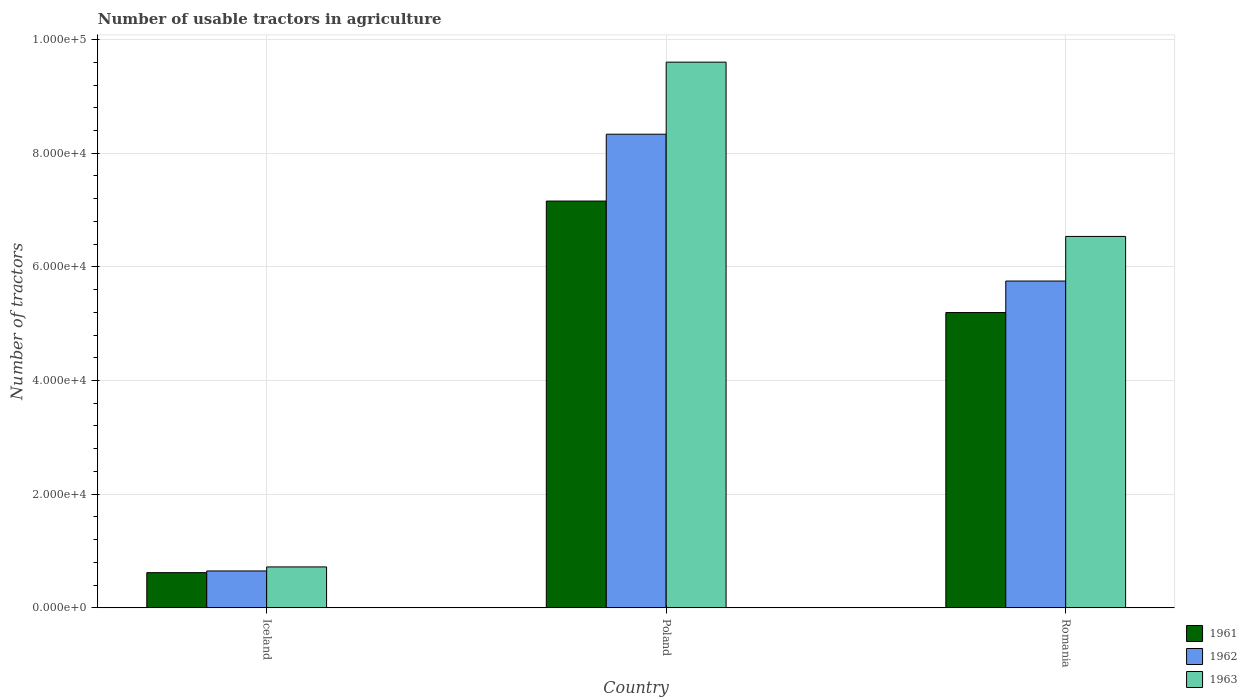How many bars are there on the 2nd tick from the left?
Your answer should be compact. 3. What is the label of the 3rd group of bars from the left?
Ensure brevity in your answer.  Romania. What is the number of usable tractors in agriculture in 1963 in Romania?
Offer a terse response. 6.54e+04. Across all countries, what is the maximum number of usable tractors in agriculture in 1961?
Make the answer very short. 7.16e+04. Across all countries, what is the minimum number of usable tractors in agriculture in 1963?
Keep it short and to the point. 7187. In which country was the number of usable tractors in agriculture in 1961 maximum?
Offer a terse response. Poland. What is the total number of usable tractors in agriculture in 1961 in the graph?
Your response must be concise. 1.30e+05. What is the difference between the number of usable tractors in agriculture in 1963 in Iceland and that in Romania?
Keep it short and to the point. -5.82e+04. What is the difference between the number of usable tractors in agriculture in 1962 in Iceland and the number of usable tractors in agriculture in 1961 in Poland?
Offer a terse response. -6.51e+04. What is the average number of usable tractors in agriculture in 1963 per country?
Your answer should be very brief. 5.62e+04. What is the difference between the number of usable tractors in agriculture of/in 1963 and number of usable tractors in agriculture of/in 1962 in Poland?
Give a very brief answer. 1.27e+04. In how many countries, is the number of usable tractors in agriculture in 1963 greater than 24000?
Your response must be concise. 2. What is the ratio of the number of usable tractors in agriculture in 1961 in Iceland to that in Romania?
Give a very brief answer. 0.12. Is the difference between the number of usable tractors in agriculture in 1963 in Iceland and Poland greater than the difference between the number of usable tractors in agriculture in 1962 in Iceland and Poland?
Your answer should be compact. No. What is the difference between the highest and the second highest number of usable tractors in agriculture in 1963?
Offer a very short reply. -8.88e+04. What is the difference between the highest and the lowest number of usable tractors in agriculture in 1961?
Offer a terse response. 6.54e+04. Is it the case that in every country, the sum of the number of usable tractors in agriculture in 1963 and number of usable tractors in agriculture in 1962 is greater than the number of usable tractors in agriculture in 1961?
Give a very brief answer. Yes. Are the values on the major ticks of Y-axis written in scientific E-notation?
Provide a succinct answer. Yes. Does the graph contain any zero values?
Your answer should be very brief. No. Where does the legend appear in the graph?
Your response must be concise. Bottom right. How many legend labels are there?
Your response must be concise. 3. How are the legend labels stacked?
Offer a very short reply. Vertical. What is the title of the graph?
Provide a short and direct response. Number of usable tractors in agriculture. Does "1993" appear as one of the legend labels in the graph?
Provide a short and direct response. No. What is the label or title of the X-axis?
Keep it short and to the point. Country. What is the label or title of the Y-axis?
Provide a short and direct response. Number of tractors. What is the Number of tractors in 1961 in Iceland?
Your answer should be very brief. 6177. What is the Number of tractors of 1962 in Iceland?
Give a very brief answer. 6479. What is the Number of tractors in 1963 in Iceland?
Make the answer very short. 7187. What is the Number of tractors in 1961 in Poland?
Your answer should be compact. 7.16e+04. What is the Number of tractors of 1962 in Poland?
Your answer should be very brief. 8.33e+04. What is the Number of tractors in 1963 in Poland?
Keep it short and to the point. 9.60e+04. What is the Number of tractors in 1961 in Romania?
Provide a short and direct response. 5.20e+04. What is the Number of tractors in 1962 in Romania?
Keep it short and to the point. 5.75e+04. What is the Number of tractors in 1963 in Romania?
Offer a terse response. 6.54e+04. Across all countries, what is the maximum Number of tractors in 1961?
Provide a succinct answer. 7.16e+04. Across all countries, what is the maximum Number of tractors of 1962?
Keep it short and to the point. 8.33e+04. Across all countries, what is the maximum Number of tractors in 1963?
Keep it short and to the point. 9.60e+04. Across all countries, what is the minimum Number of tractors in 1961?
Your answer should be compact. 6177. Across all countries, what is the minimum Number of tractors of 1962?
Offer a very short reply. 6479. Across all countries, what is the minimum Number of tractors in 1963?
Your response must be concise. 7187. What is the total Number of tractors of 1961 in the graph?
Provide a succinct answer. 1.30e+05. What is the total Number of tractors of 1962 in the graph?
Give a very brief answer. 1.47e+05. What is the total Number of tractors of 1963 in the graph?
Provide a short and direct response. 1.69e+05. What is the difference between the Number of tractors of 1961 in Iceland and that in Poland?
Provide a succinct answer. -6.54e+04. What is the difference between the Number of tractors of 1962 in Iceland and that in Poland?
Offer a very short reply. -7.69e+04. What is the difference between the Number of tractors in 1963 in Iceland and that in Poland?
Provide a succinct answer. -8.88e+04. What is the difference between the Number of tractors of 1961 in Iceland and that in Romania?
Offer a terse response. -4.58e+04. What is the difference between the Number of tractors in 1962 in Iceland and that in Romania?
Ensure brevity in your answer.  -5.10e+04. What is the difference between the Number of tractors in 1963 in Iceland and that in Romania?
Your answer should be very brief. -5.82e+04. What is the difference between the Number of tractors in 1961 in Poland and that in Romania?
Offer a very short reply. 1.96e+04. What is the difference between the Number of tractors in 1962 in Poland and that in Romania?
Your answer should be compact. 2.58e+04. What is the difference between the Number of tractors of 1963 in Poland and that in Romania?
Your response must be concise. 3.07e+04. What is the difference between the Number of tractors of 1961 in Iceland and the Number of tractors of 1962 in Poland?
Provide a short and direct response. -7.72e+04. What is the difference between the Number of tractors in 1961 in Iceland and the Number of tractors in 1963 in Poland?
Your response must be concise. -8.98e+04. What is the difference between the Number of tractors in 1962 in Iceland and the Number of tractors in 1963 in Poland?
Provide a succinct answer. -8.95e+04. What is the difference between the Number of tractors of 1961 in Iceland and the Number of tractors of 1962 in Romania?
Offer a terse response. -5.13e+04. What is the difference between the Number of tractors of 1961 in Iceland and the Number of tractors of 1963 in Romania?
Provide a short and direct response. -5.92e+04. What is the difference between the Number of tractors of 1962 in Iceland and the Number of tractors of 1963 in Romania?
Provide a short and direct response. -5.89e+04. What is the difference between the Number of tractors in 1961 in Poland and the Number of tractors in 1962 in Romania?
Provide a short and direct response. 1.41e+04. What is the difference between the Number of tractors in 1961 in Poland and the Number of tractors in 1963 in Romania?
Provide a succinct answer. 6226. What is the difference between the Number of tractors in 1962 in Poland and the Number of tractors in 1963 in Romania?
Provide a short and direct response. 1.80e+04. What is the average Number of tractors of 1961 per country?
Your response must be concise. 4.32e+04. What is the average Number of tractors of 1962 per country?
Make the answer very short. 4.91e+04. What is the average Number of tractors of 1963 per country?
Offer a terse response. 5.62e+04. What is the difference between the Number of tractors of 1961 and Number of tractors of 1962 in Iceland?
Your response must be concise. -302. What is the difference between the Number of tractors in 1961 and Number of tractors in 1963 in Iceland?
Your response must be concise. -1010. What is the difference between the Number of tractors of 1962 and Number of tractors of 1963 in Iceland?
Ensure brevity in your answer.  -708. What is the difference between the Number of tractors of 1961 and Number of tractors of 1962 in Poland?
Make the answer very short. -1.18e+04. What is the difference between the Number of tractors in 1961 and Number of tractors in 1963 in Poland?
Provide a short and direct response. -2.44e+04. What is the difference between the Number of tractors of 1962 and Number of tractors of 1963 in Poland?
Your answer should be compact. -1.27e+04. What is the difference between the Number of tractors of 1961 and Number of tractors of 1962 in Romania?
Provide a succinct answer. -5548. What is the difference between the Number of tractors of 1961 and Number of tractors of 1963 in Romania?
Keep it short and to the point. -1.34e+04. What is the difference between the Number of tractors of 1962 and Number of tractors of 1963 in Romania?
Your response must be concise. -7851. What is the ratio of the Number of tractors of 1961 in Iceland to that in Poland?
Make the answer very short. 0.09. What is the ratio of the Number of tractors of 1962 in Iceland to that in Poland?
Give a very brief answer. 0.08. What is the ratio of the Number of tractors in 1963 in Iceland to that in Poland?
Give a very brief answer. 0.07. What is the ratio of the Number of tractors of 1961 in Iceland to that in Romania?
Your answer should be very brief. 0.12. What is the ratio of the Number of tractors of 1962 in Iceland to that in Romania?
Make the answer very short. 0.11. What is the ratio of the Number of tractors of 1963 in Iceland to that in Romania?
Offer a very short reply. 0.11. What is the ratio of the Number of tractors of 1961 in Poland to that in Romania?
Your answer should be compact. 1.38. What is the ratio of the Number of tractors of 1962 in Poland to that in Romania?
Provide a succinct answer. 1.45. What is the ratio of the Number of tractors in 1963 in Poland to that in Romania?
Provide a succinct answer. 1.47. What is the difference between the highest and the second highest Number of tractors in 1961?
Your answer should be very brief. 1.96e+04. What is the difference between the highest and the second highest Number of tractors of 1962?
Offer a very short reply. 2.58e+04. What is the difference between the highest and the second highest Number of tractors of 1963?
Offer a terse response. 3.07e+04. What is the difference between the highest and the lowest Number of tractors of 1961?
Keep it short and to the point. 6.54e+04. What is the difference between the highest and the lowest Number of tractors of 1962?
Provide a succinct answer. 7.69e+04. What is the difference between the highest and the lowest Number of tractors of 1963?
Offer a terse response. 8.88e+04. 